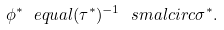<formula> <loc_0><loc_0><loc_500><loc_500>\phi ^ { * } \ e q u a l ( \tau ^ { * } ) ^ { - 1 } \ s m a l c i r c \sigma ^ { * } .</formula> 